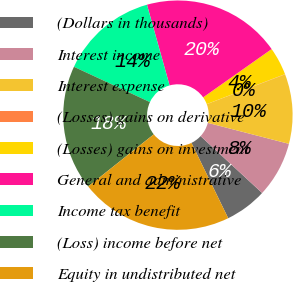Convert chart. <chart><loc_0><loc_0><loc_500><loc_500><pie_chart><fcel>(Dollars in thousands)<fcel>Interest income<fcel>Interest expense<fcel>(Losses) gains on derivative<fcel>(Losses) gains on investment<fcel>General and administrative<fcel>Income tax benefit<fcel>(Loss) income before net<fcel>Equity in undistributed net<nl><fcel>5.9%<fcel>7.85%<fcel>9.81%<fcel>0.04%<fcel>3.95%<fcel>19.58%<fcel>13.72%<fcel>17.62%<fcel>21.53%<nl></chart> 